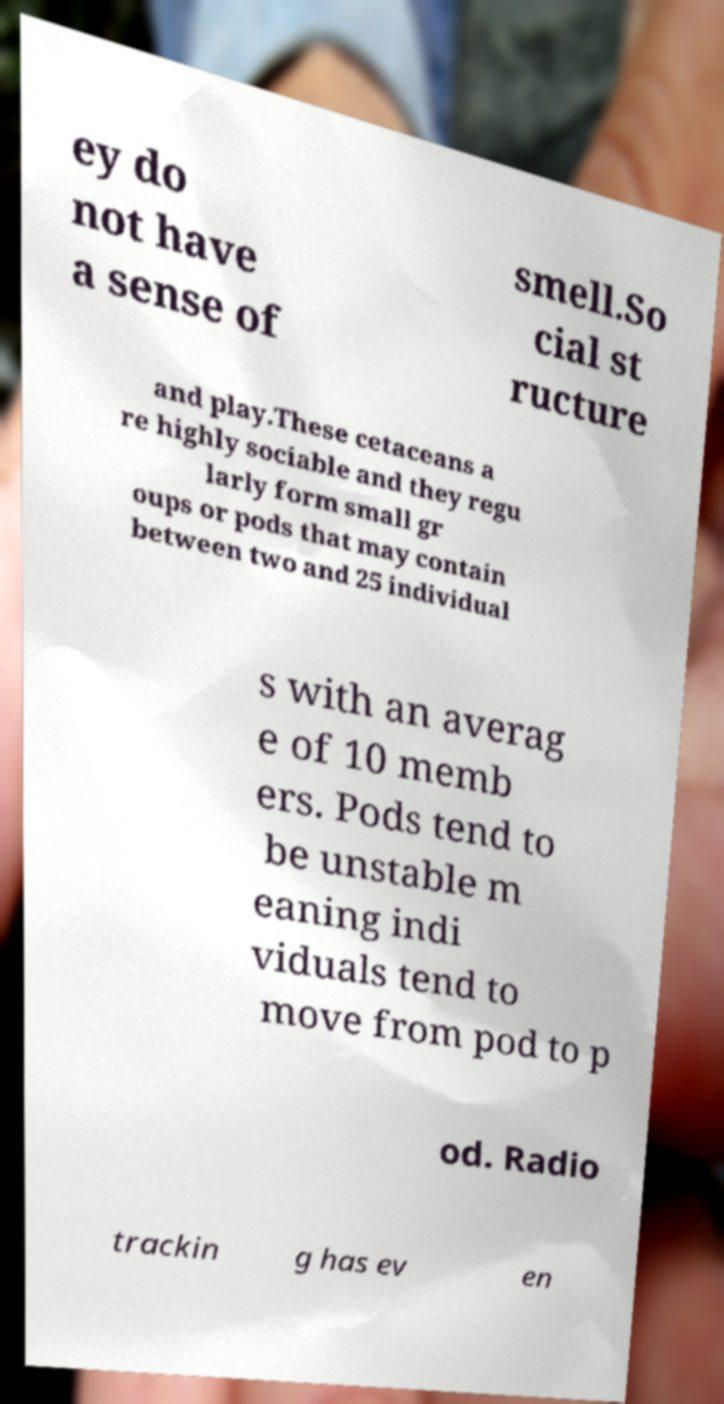There's text embedded in this image that I need extracted. Can you transcribe it verbatim? ey do not have a sense of smell.So cial st ructure and play.These cetaceans a re highly sociable and they regu larly form small gr oups or pods that may contain between two and 25 individual s with an averag e of 10 memb ers. Pods tend to be unstable m eaning indi viduals tend to move from pod to p od. Radio trackin g has ev en 